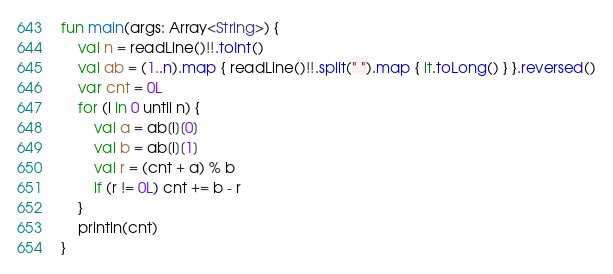<code> <loc_0><loc_0><loc_500><loc_500><_Kotlin_>fun main(args: Array<String>) {
    val n = readLine()!!.toInt()
    val ab = (1..n).map { readLine()!!.split(" ").map { it.toLong() } }.reversed()
    var cnt = 0L
    for (i in 0 until n) {
        val a = ab[i][0]
        val b = ab[i][1]
        val r = (cnt + a) % b
        if (r != 0L) cnt += b - r
    }
    println(cnt)
}</code> 